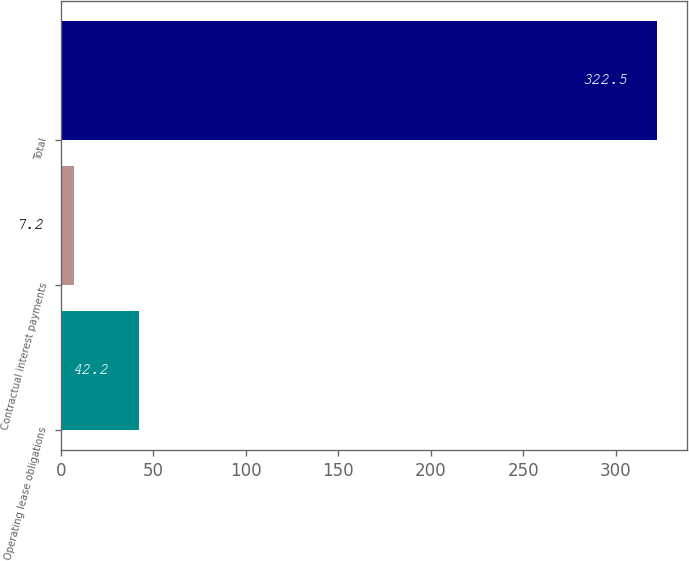Convert chart. <chart><loc_0><loc_0><loc_500><loc_500><bar_chart><fcel>Operating lease obligations<fcel>Contractual interest payments<fcel>Total<nl><fcel>42.2<fcel>7.2<fcel>322.5<nl></chart> 